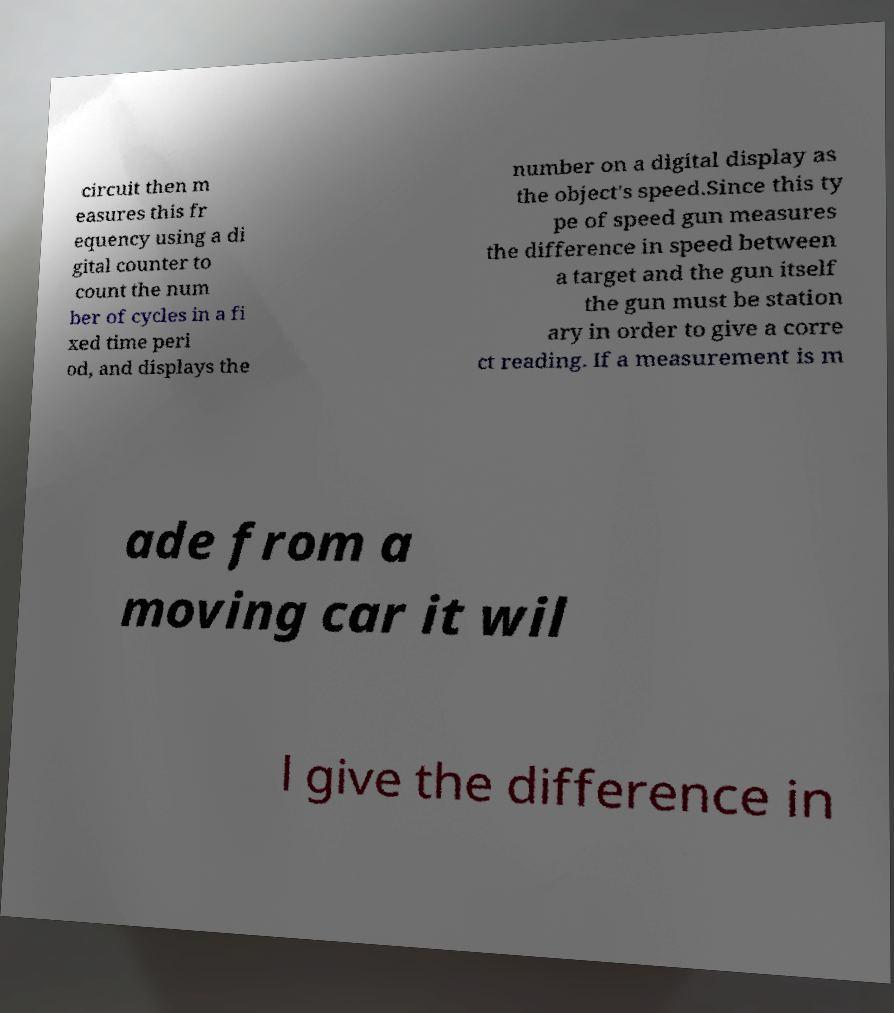What messages or text are displayed in this image? I need them in a readable, typed format. circuit then m easures this fr equency using a di gital counter to count the num ber of cycles in a fi xed time peri od, and displays the number on a digital display as the object's speed.Since this ty pe of speed gun measures the difference in speed between a target and the gun itself the gun must be station ary in order to give a corre ct reading. If a measurement is m ade from a moving car it wil l give the difference in 